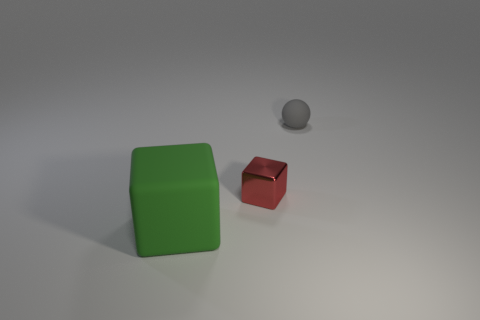What number of other objects are the same material as the gray sphere?
Your answer should be compact. 1. What is the shape of the object in front of the cube to the right of the object that is in front of the red block?
Your answer should be very brief. Cube. Are there fewer small gray things that are right of the small gray matte sphere than tiny red shiny cubes right of the large green matte cube?
Offer a very short reply. Yes. Is there a big block that has the same color as the large rubber object?
Make the answer very short. No. Does the sphere have the same material as the object on the left side of the metal block?
Your answer should be compact. Yes. Are there any tiny shiny blocks left of the rubber object that is in front of the small gray matte object?
Make the answer very short. No. How big is the red metal thing?
Provide a succinct answer. Small. What number of gray things have the same size as the red metal block?
Your answer should be very brief. 1. Is the material of the small thing that is on the left side of the tiny gray matte sphere the same as the block to the left of the red shiny object?
Your response must be concise. No. The small thing in front of the rubber object behind the tiny block is made of what material?
Your response must be concise. Metal. 